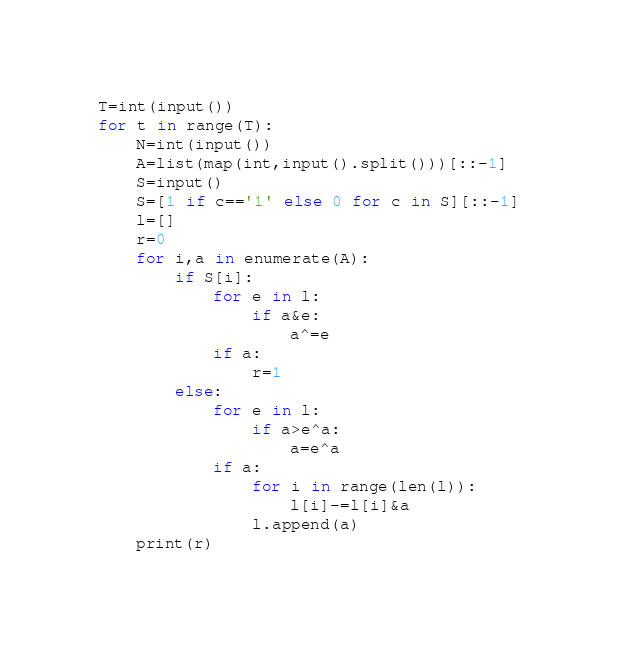Convert code to text. <code><loc_0><loc_0><loc_500><loc_500><_Python_>T=int(input())
for t in range(T):
    N=int(input())
    A=list(map(int,input().split()))[::-1]
    S=input()
    S=[1 if c=='1' else 0 for c in S][::-1]
    l=[]
    r=0
    for i,a in enumerate(A):
        if S[i]:
            for e in l:
                if a&e:
                    a^=e
            if a:
                r=1
        else:
            for e in l:
                if a>e^a:
                    a=e^a
            if a:
                for i in range(len(l)):
                    l[i]-=l[i]&a
                l.append(a)
    print(r)</code> 